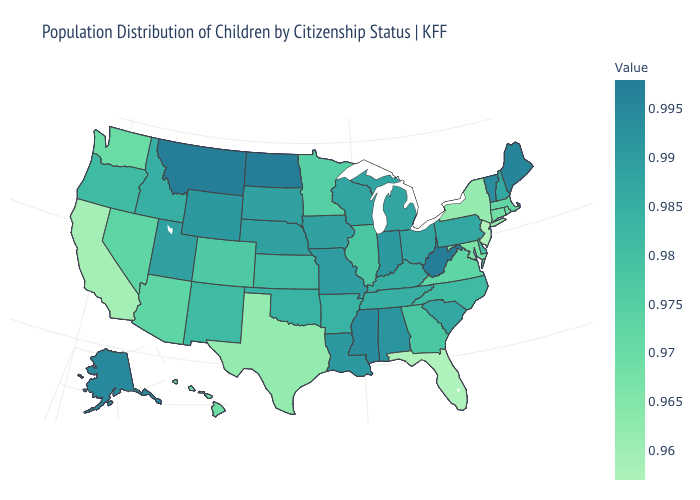Is the legend a continuous bar?
Keep it brief. Yes. Does Connecticut have a lower value than Wyoming?
Quick response, please. Yes. Does Louisiana have a lower value than Kansas?
Quick response, please. No. Among the states that border West Virginia , which have the lowest value?
Quick response, please. Maryland. 